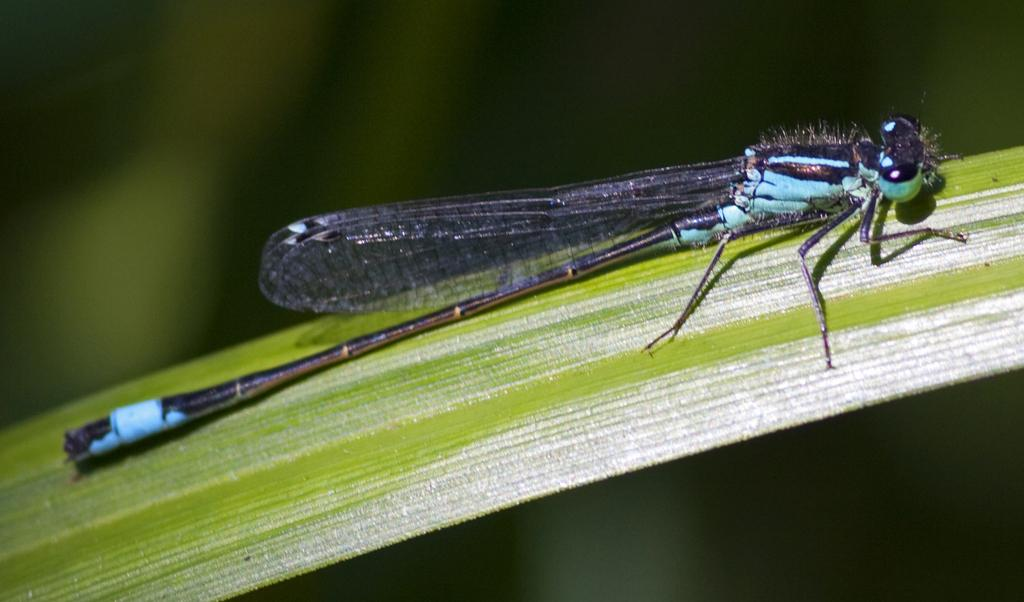What type of insect is in the image? There is a net-winged insect in the image. What is in the foreground of the image? There is a leaf in the front of the image. Can you describe the background of the image? The background of the image is blurry. How many apples are on the pizzas in the image? There are no apples or pizzas present in the image. 